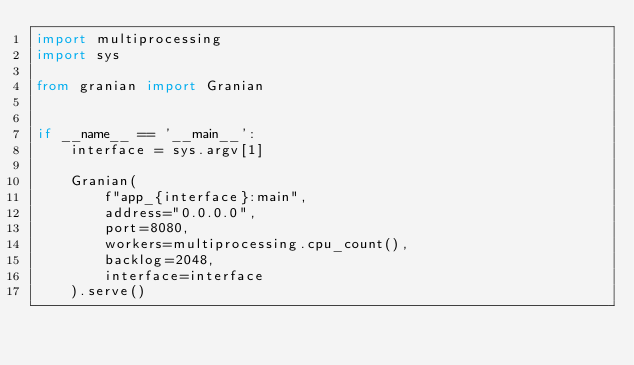Convert code to text. <code><loc_0><loc_0><loc_500><loc_500><_Python_>import multiprocessing
import sys

from granian import Granian


if __name__ == '__main__':
    interface = sys.argv[1]

    Granian(
        f"app_{interface}:main",
        address="0.0.0.0",
        port=8080,
        workers=multiprocessing.cpu_count(),
        backlog=2048,
        interface=interface
    ).serve()
</code> 